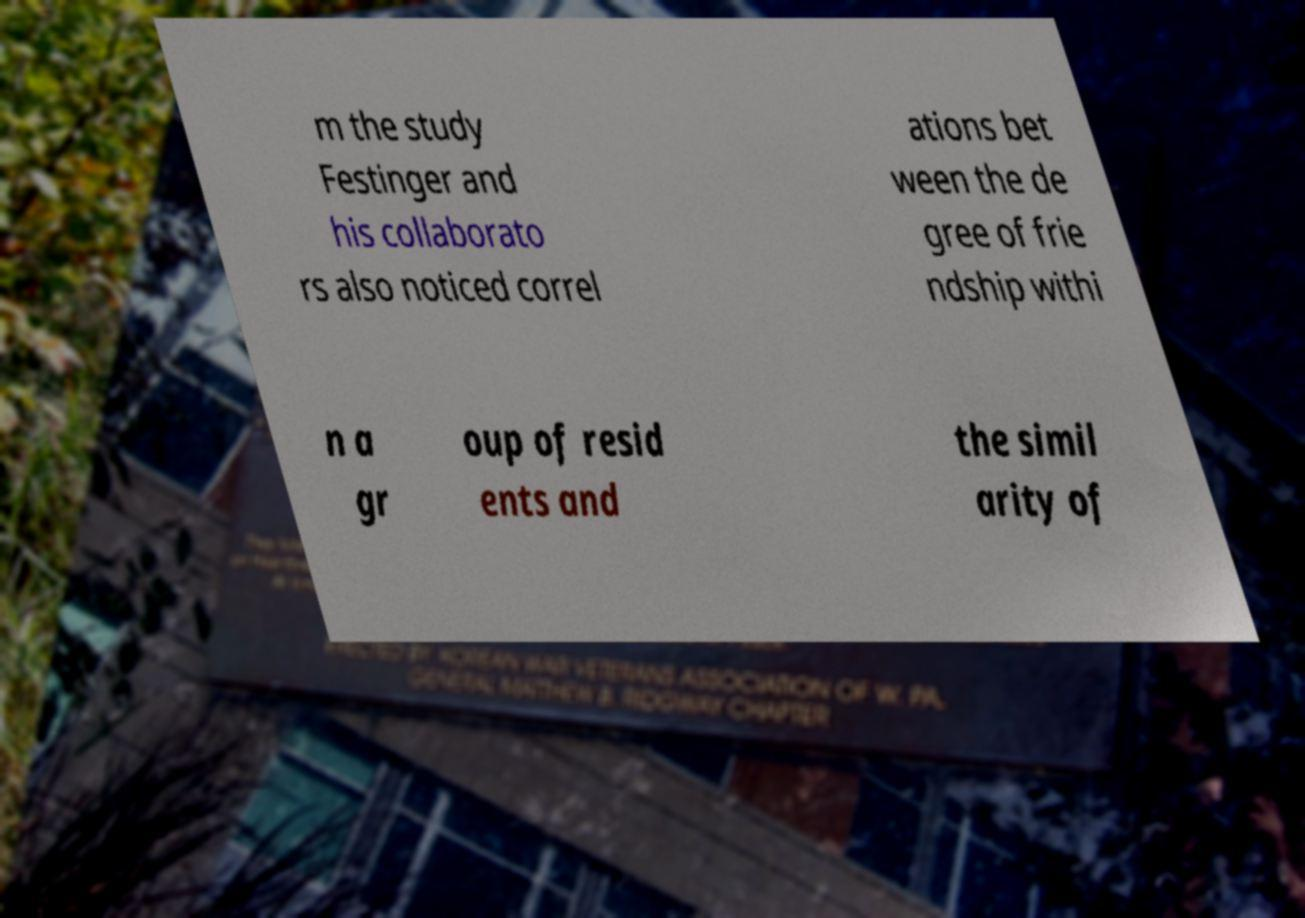I need the written content from this picture converted into text. Can you do that? m the study Festinger and his collaborato rs also noticed correl ations bet ween the de gree of frie ndship withi n a gr oup of resid ents and the simil arity of 